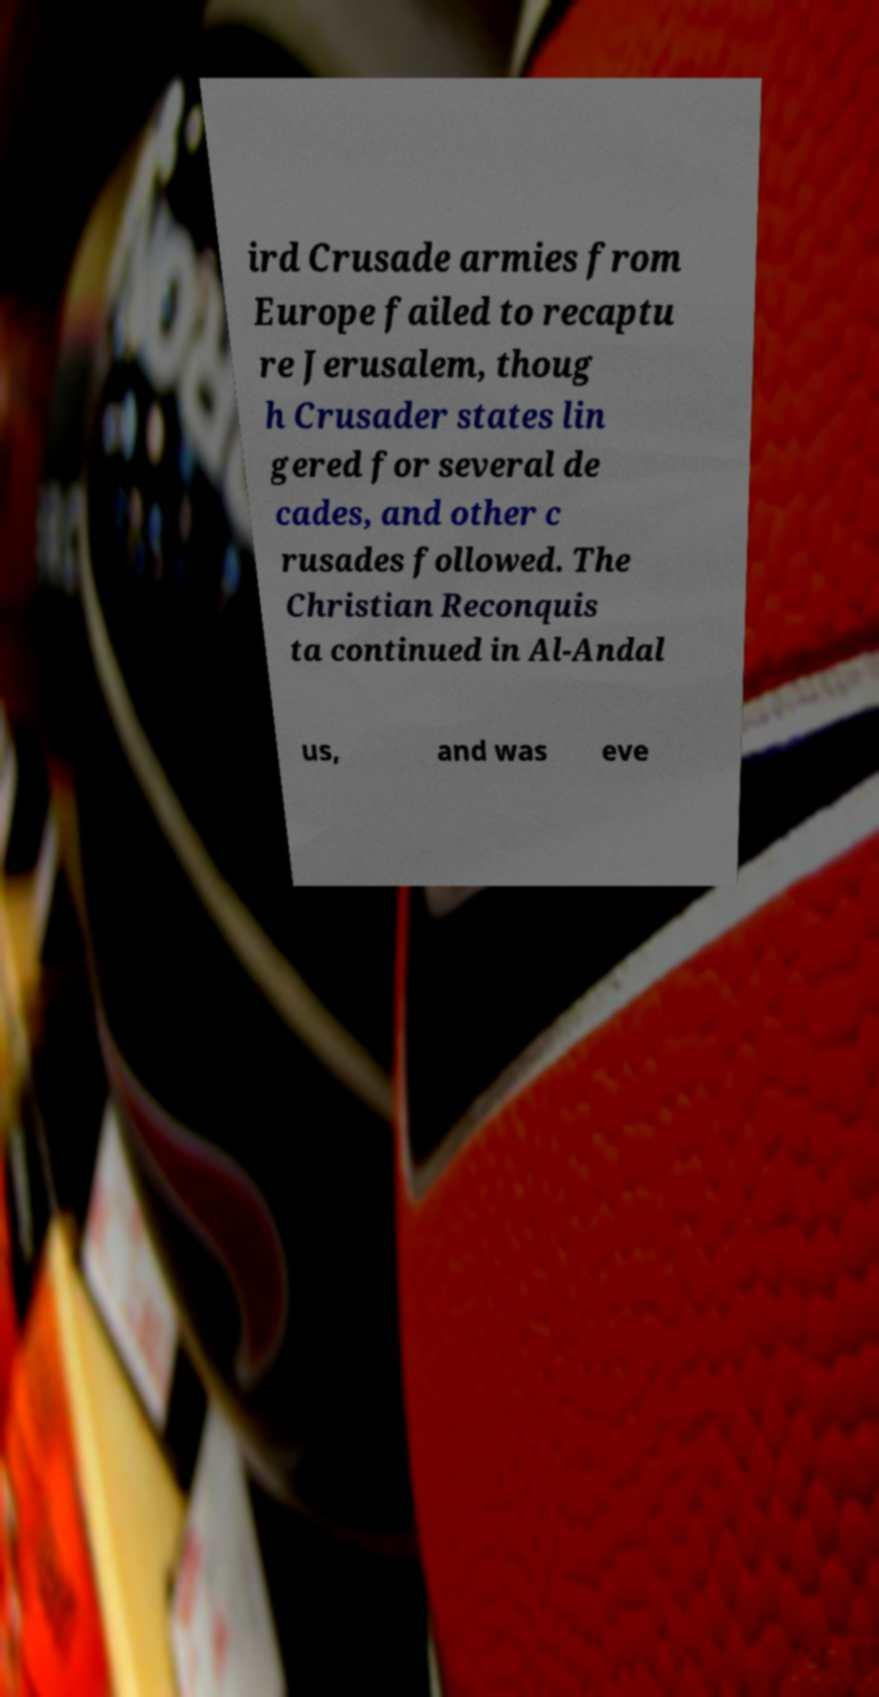Can you accurately transcribe the text from the provided image for me? ird Crusade armies from Europe failed to recaptu re Jerusalem, thoug h Crusader states lin gered for several de cades, and other c rusades followed. The Christian Reconquis ta continued in Al-Andal us, and was eve 